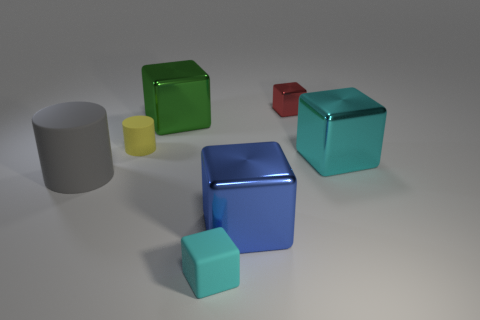Subtract all purple blocks. Subtract all yellow spheres. How many blocks are left? 5 Add 1 small cyan things. How many objects exist? 8 Subtract all cubes. How many objects are left? 2 Subtract all big red metal cylinders. Subtract all small cyan objects. How many objects are left? 6 Add 2 green things. How many green things are left? 3 Add 5 big yellow balls. How many big yellow balls exist? 5 Subtract 0 green spheres. How many objects are left? 7 